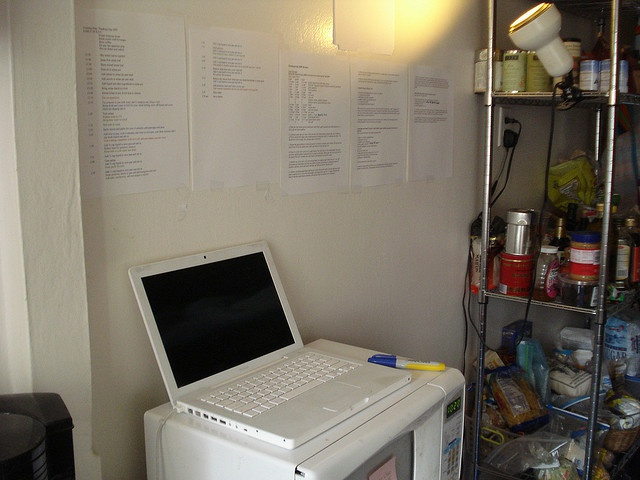Describe the objects in this image and their specific colors. I can see laptop in gray, darkgray, black, and lightgray tones, microwave in gray, darkgray, and lightgray tones, bottle in gray, black, maroon, and darkgray tones, bottle in gray, black, and maroon tones, and bottle in gray, black, maroon, and olive tones in this image. 